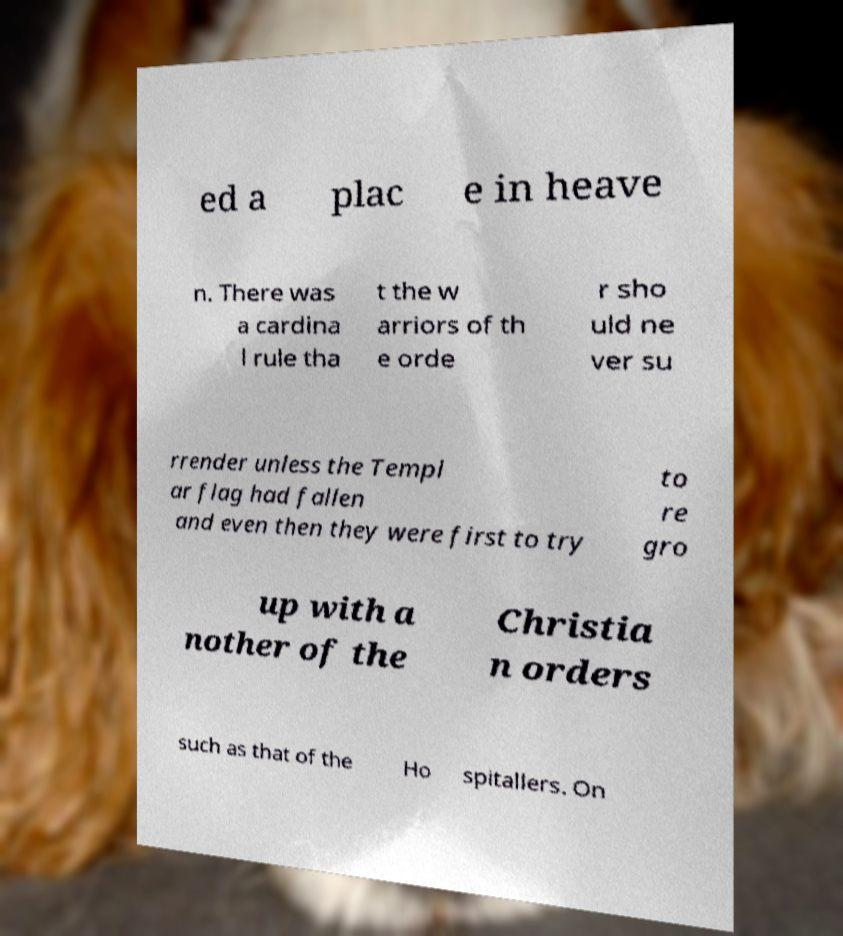For documentation purposes, I need the text within this image transcribed. Could you provide that? ed a plac e in heave n. There was a cardina l rule tha t the w arriors of th e orde r sho uld ne ver su rrender unless the Templ ar flag had fallen and even then they were first to try to re gro up with a nother of the Christia n orders such as that of the Ho spitallers. On 